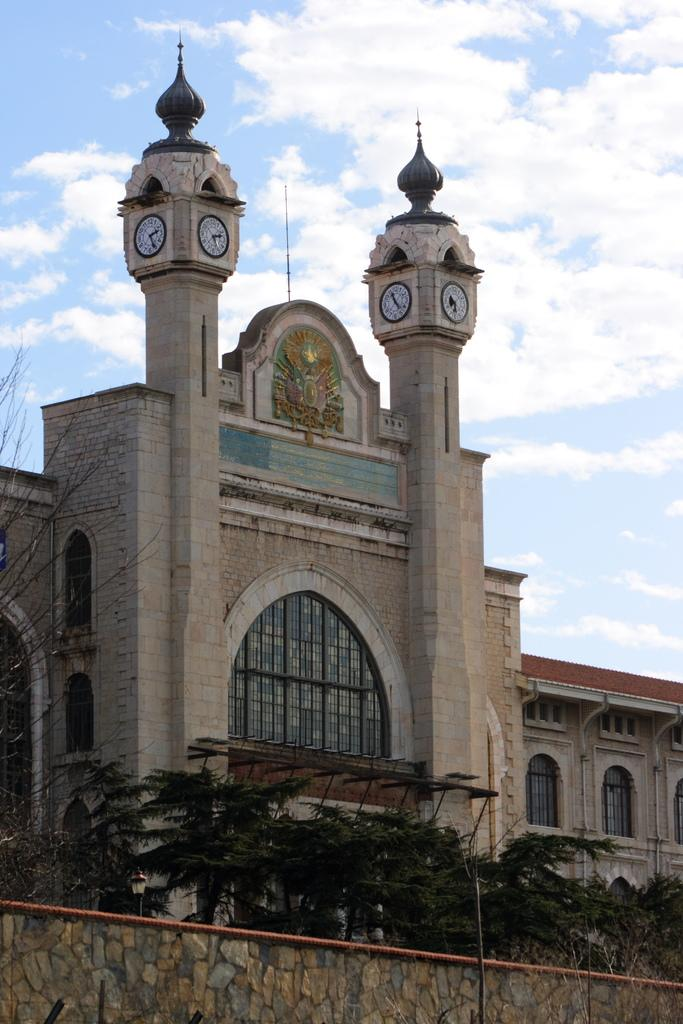What is the main structure in the center of the image? There is a building in the center of the image. What can be seen at the bottom of the image? There are trees and a wall at the bottom of the image. What is visible in the background of the image? The sky is visible in the background of the image. How many weeks does the coach in the image last? There is no coach present in the image, so it is not possible to determine how long it lasts. 